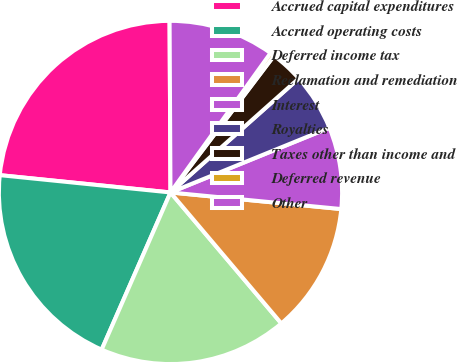Convert chart. <chart><loc_0><loc_0><loc_500><loc_500><pie_chart><fcel>Accrued capital expenditures<fcel>Accrued operating costs<fcel>Deferred income tax<fcel>Reclamation and remediation<fcel>Interest<fcel>Royalties<fcel>Taxes other than income and<fcel>Deferred revenue<fcel>Other<nl><fcel>23.31%<fcel>20.04%<fcel>17.75%<fcel>12.28%<fcel>7.7%<fcel>5.41%<fcel>3.12%<fcel>0.41%<fcel>9.99%<nl></chart> 